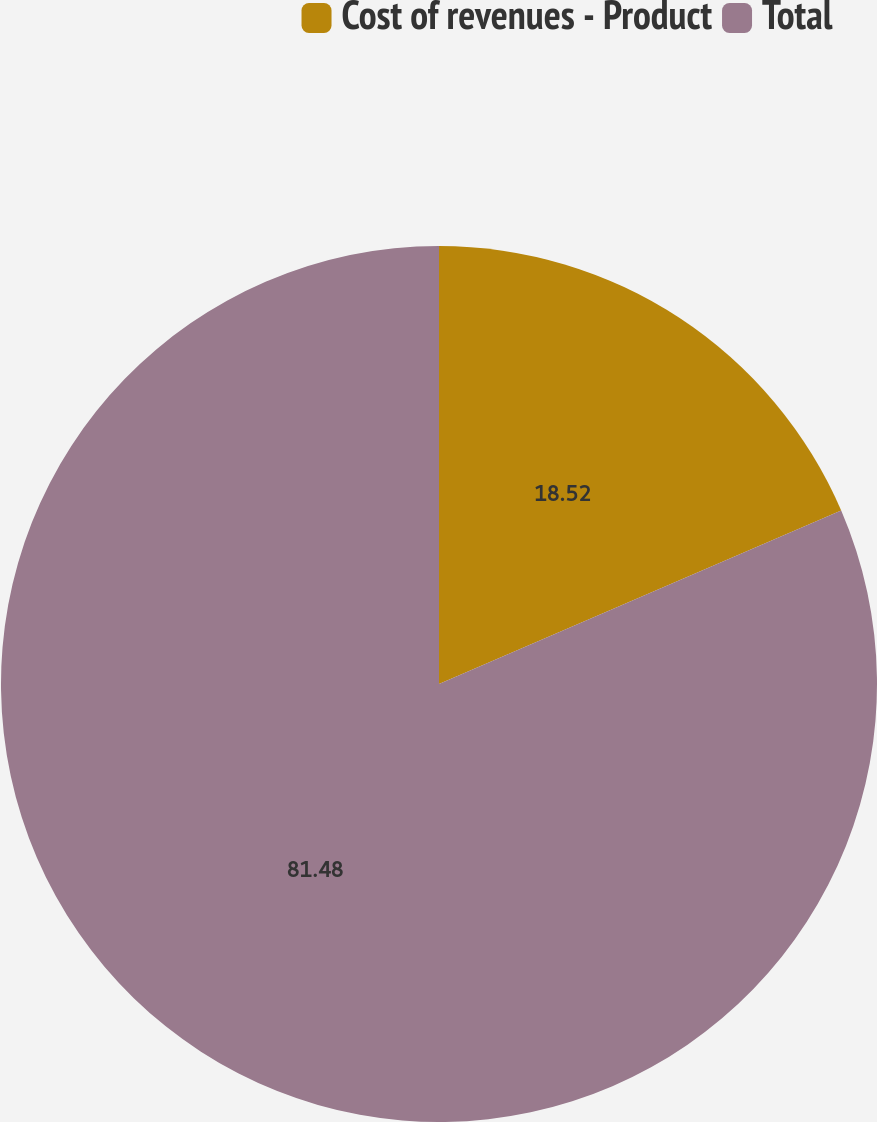Convert chart to OTSL. <chart><loc_0><loc_0><loc_500><loc_500><pie_chart><fcel>Cost of revenues - Product<fcel>Total<nl><fcel>18.52%<fcel>81.48%<nl></chart> 